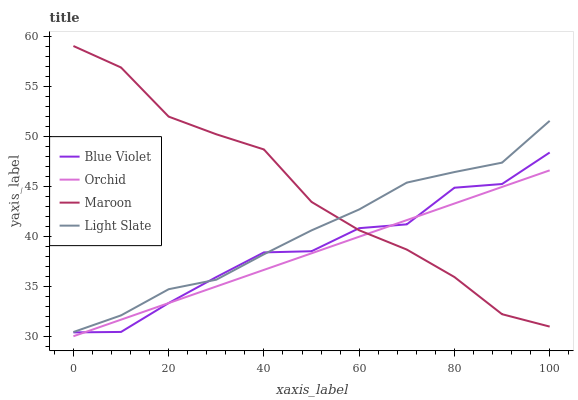Does Orchid have the minimum area under the curve?
Answer yes or no. Yes. Does Maroon have the maximum area under the curve?
Answer yes or no. Yes. Does Blue Violet have the minimum area under the curve?
Answer yes or no. No. Does Blue Violet have the maximum area under the curve?
Answer yes or no. No. Is Orchid the smoothest?
Answer yes or no. Yes. Is Blue Violet the roughest?
Answer yes or no. Yes. Is Maroon the smoothest?
Answer yes or no. No. Is Maroon the roughest?
Answer yes or no. No. Does Orchid have the lowest value?
Answer yes or no. Yes. Does Blue Violet have the lowest value?
Answer yes or no. No. Does Maroon have the highest value?
Answer yes or no. Yes. Does Blue Violet have the highest value?
Answer yes or no. No. Is Orchid less than Light Slate?
Answer yes or no. Yes. Is Light Slate greater than Orchid?
Answer yes or no. Yes. Does Maroon intersect Blue Violet?
Answer yes or no. Yes. Is Maroon less than Blue Violet?
Answer yes or no. No. Is Maroon greater than Blue Violet?
Answer yes or no. No. Does Orchid intersect Light Slate?
Answer yes or no. No. 